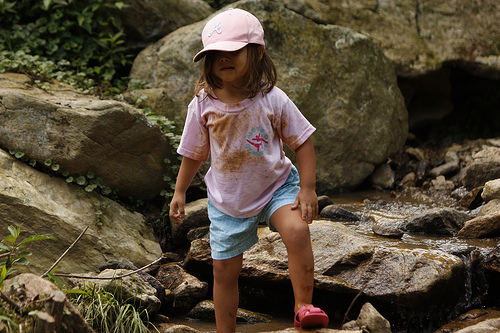<image>
Is the girl on the rock? No. The girl is not positioned on the rock. They may be near each other, but the girl is not supported by or resting on top of the rock. Is there a girl next to the rock? Yes. The girl is positioned adjacent to the rock, located nearby in the same general area. 